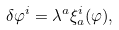<formula> <loc_0><loc_0><loc_500><loc_500>\delta \varphi ^ { i } = \lambda ^ { a } \xi _ { a } ^ { i } ( \varphi ) ,</formula> 